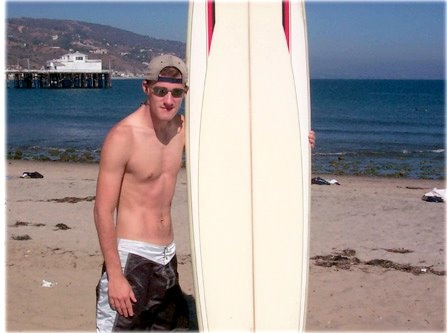Describe the objects in this image and their specific colors. I can see surfboard in white, ivory, tan, and brown tones and people in white, brown, salmon, and black tones in this image. 